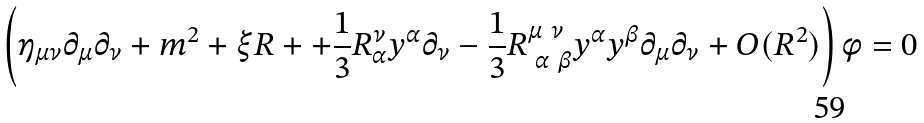<formula> <loc_0><loc_0><loc_500><loc_500>\left ( \eta _ { \mu \nu } \partial _ { \mu } \partial _ { \nu } + m ^ { 2 } + \xi R + + { \frac { 1 } { 3 } } R _ { \alpha } ^ { \nu } y ^ { \alpha } \partial _ { \nu } - { \frac { 1 } { 3 } } R _ { \ \alpha \ \beta } ^ { \mu \ \nu } y ^ { \alpha } y ^ { \beta } \partial _ { \mu } \partial _ { \nu } + O ( R ^ { 2 } ) \right ) \phi = 0</formula> 